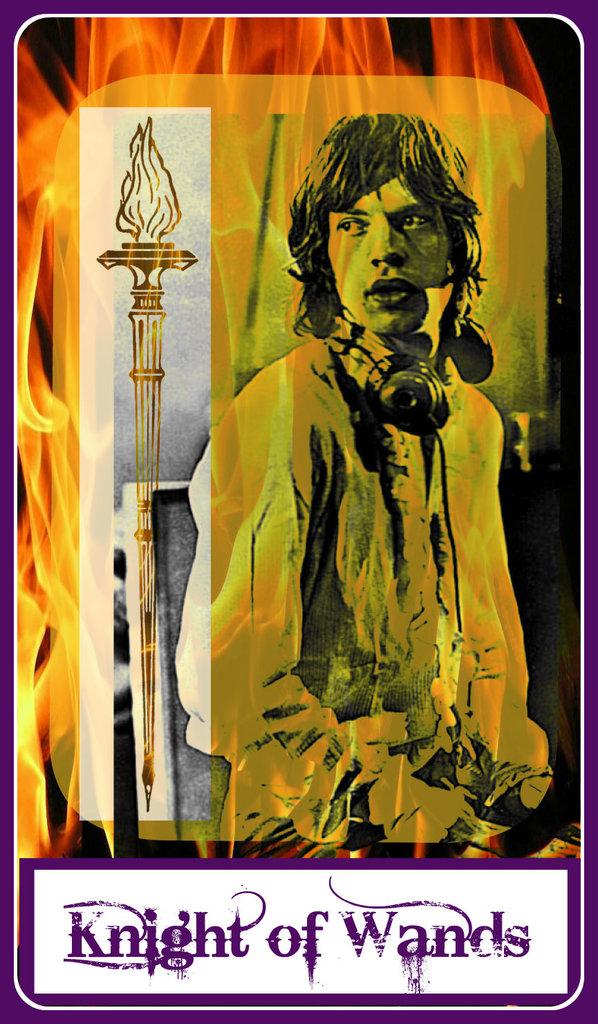What does this poster say?
Offer a very short reply. Knight of wands. 